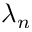Convert formula to latex. <formula><loc_0><loc_0><loc_500><loc_500>\lambda _ { n }</formula> 